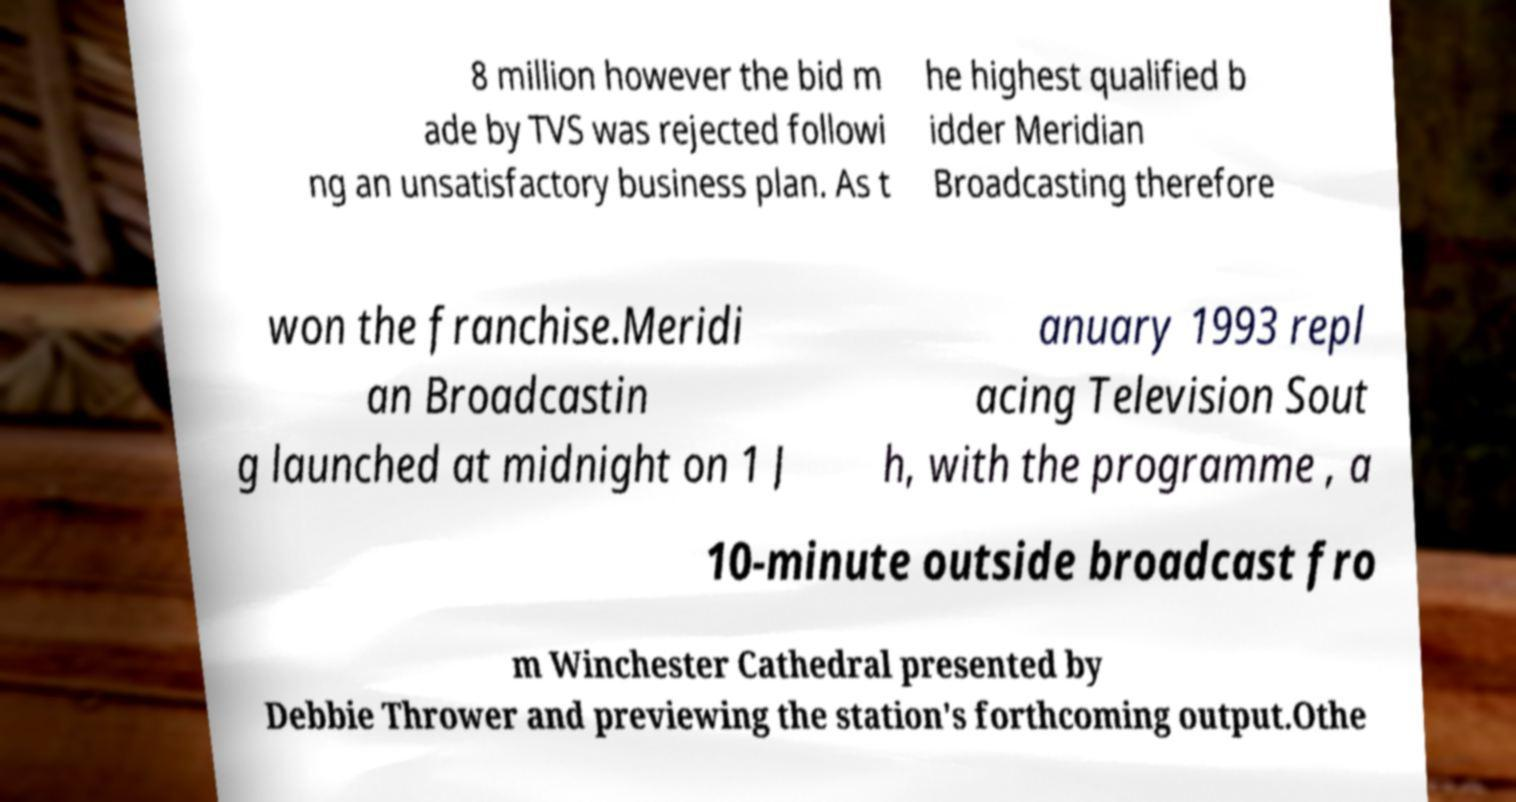Can you accurately transcribe the text from the provided image for me? 8 million however the bid m ade by TVS was rejected followi ng an unsatisfactory business plan. As t he highest qualified b idder Meridian Broadcasting therefore won the franchise.Meridi an Broadcastin g launched at midnight on 1 J anuary 1993 repl acing Television Sout h, with the programme , a 10-minute outside broadcast fro m Winchester Cathedral presented by Debbie Thrower and previewing the station's forthcoming output.Othe 